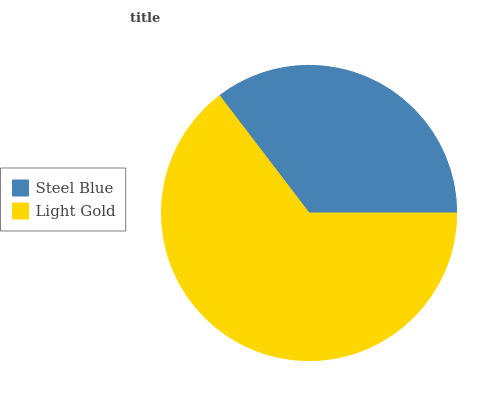Is Steel Blue the minimum?
Answer yes or no. Yes. Is Light Gold the maximum?
Answer yes or no. Yes. Is Light Gold the minimum?
Answer yes or no. No. Is Light Gold greater than Steel Blue?
Answer yes or no. Yes. Is Steel Blue less than Light Gold?
Answer yes or no. Yes. Is Steel Blue greater than Light Gold?
Answer yes or no. No. Is Light Gold less than Steel Blue?
Answer yes or no. No. Is Light Gold the high median?
Answer yes or no. Yes. Is Steel Blue the low median?
Answer yes or no. Yes. Is Steel Blue the high median?
Answer yes or no. No. Is Light Gold the low median?
Answer yes or no. No. 